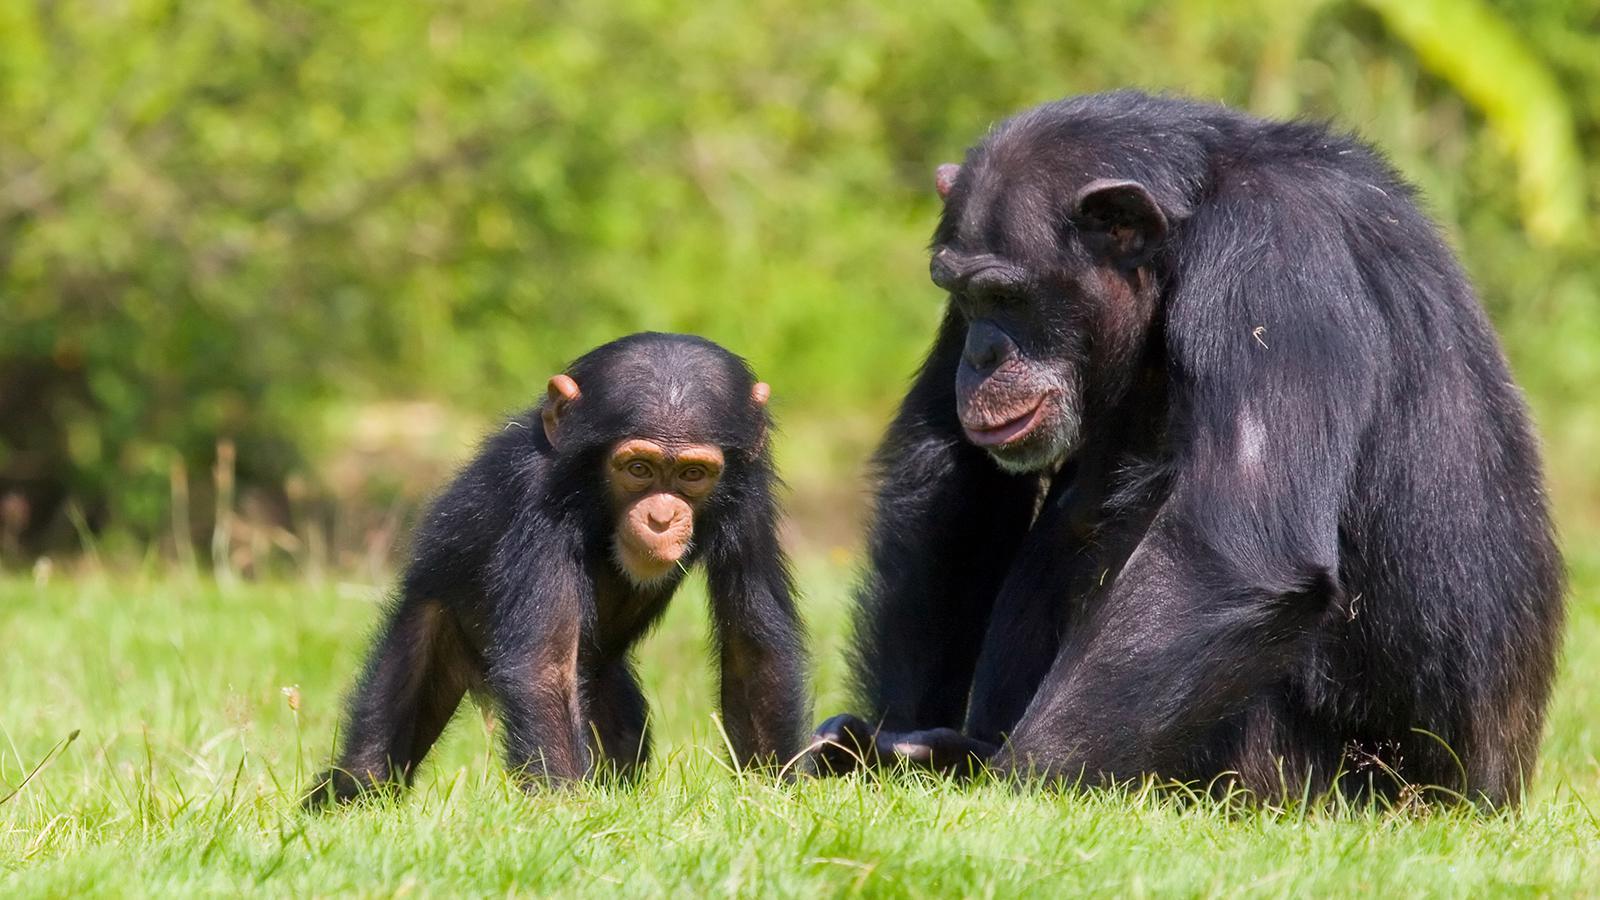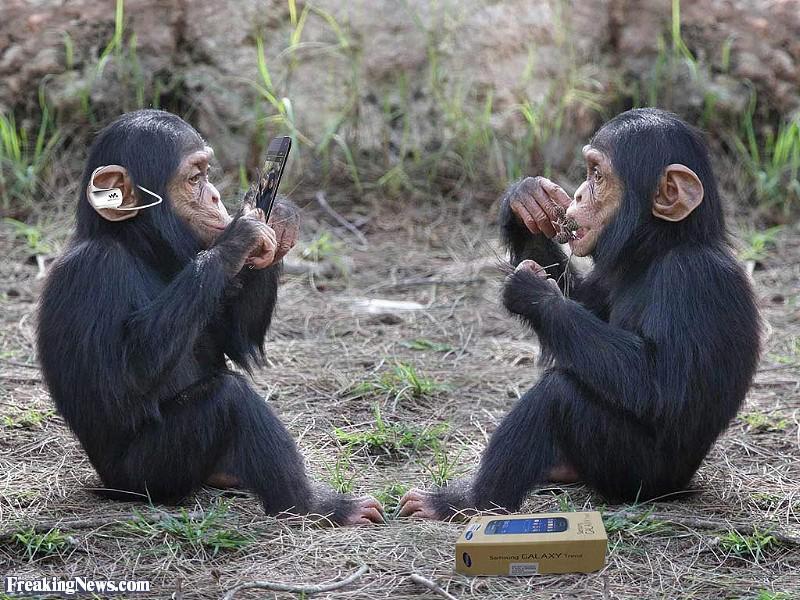The first image is the image on the left, the second image is the image on the right. For the images displayed, is the sentence "Each image shows a larger animal hugging a smaller one." factually correct? Answer yes or no. No. 